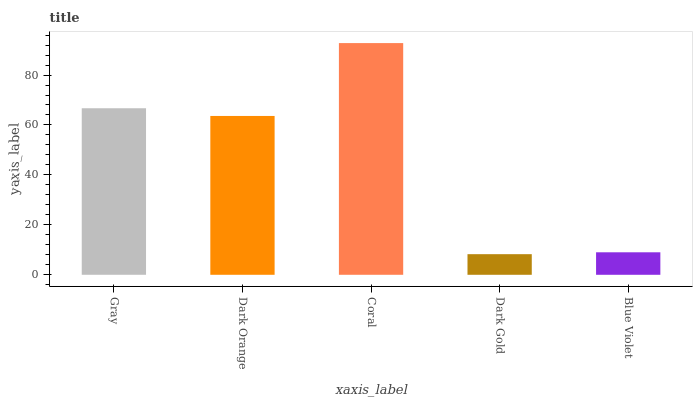Is Dark Gold the minimum?
Answer yes or no. Yes. Is Coral the maximum?
Answer yes or no. Yes. Is Dark Orange the minimum?
Answer yes or no. No. Is Dark Orange the maximum?
Answer yes or no. No. Is Gray greater than Dark Orange?
Answer yes or no. Yes. Is Dark Orange less than Gray?
Answer yes or no. Yes. Is Dark Orange greater than Gray?
Answer yes or no. No. Is Gray less than Dark Orange?
Answer yes or no. No. Is Dark Orange the high median?
Answer yes or no. Yes. Is Dark Orange the low median?
Answer yes or no. Yes. Is Blue Violet the high median?
Answer yes or no. No. Is Dark Gold the low median?
Answer yes or no. No. 